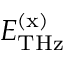<formula> <loc_0><loc_0><loc_500><loc_500>E _ { T H z } ^ { ( x ) }</formula> 